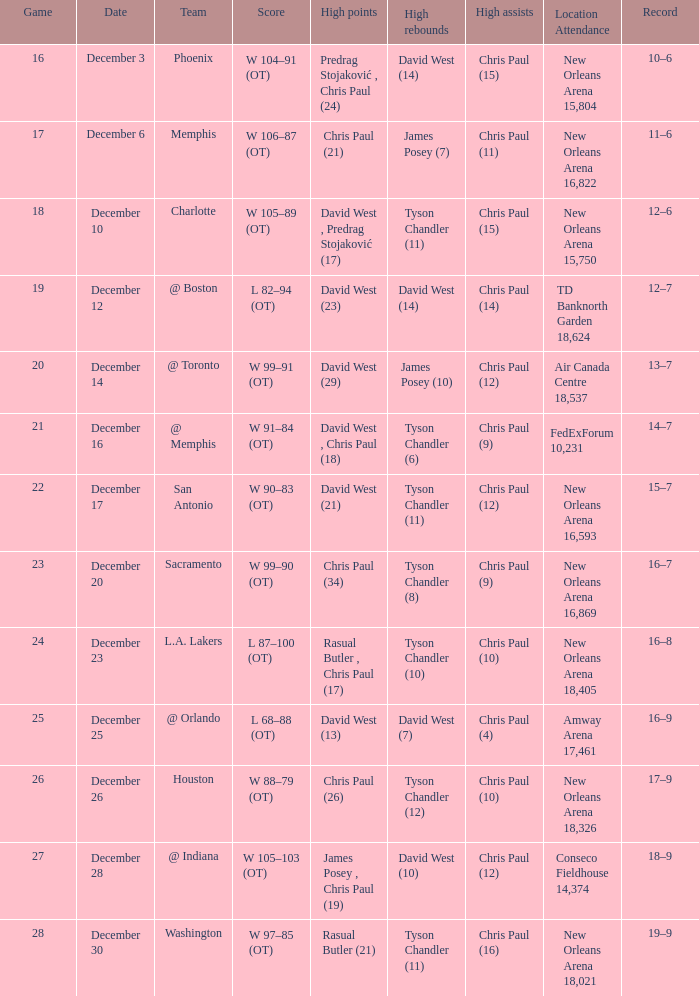What is Date, when Location Attendance is "TD Banknorth Garden 18,624"? December 12. 